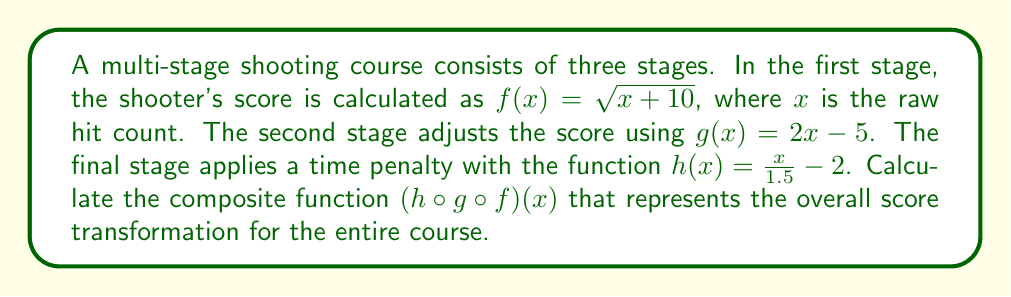What is the answer to this math problem? To compute the composite function $(h \circ g \circ f)(x)$, we need to apply the functions in order from right to left:

1. Start with $f(x) = \sqrt{x + 10}$

2. Apply $g$ to $f(x)$:
   $g(f(x)) = 2(\sqrt{x + 10}) - 5$

3. Finally, apply $h$ to $g(f(x))$:
   $h(g(f(x))) = \frac{2(\sqrt{x + 10}) - 5}{1.5} - 2$

4. Simplify:
   $$\begin{align*}
   (h \circ g \circ f)(x) &= \frac{2(\sqrt{x + 10}) - 5}{1.5} - 2 \\[6pt]
   &= \frac{2\sqrt{x + 10}}{1.5} - \frac{5}{1.5} - 2 \\[6pt]
   &= \frac{4\sqrt{x + 10}}{3} - \frac{10}{3} - 2 \\[6pt]
   &= \frac{4\sqrt{x + 10}}{3} - \frac{16}{3}
   \end{align*}$$

This final expression represents the composite function for the entire multi-stage shooting course.
Answer: $(h \circ g \circ f)(x) = \frac{4\sqrt{x + 10}}{3} - \frac{16}{3}$ 